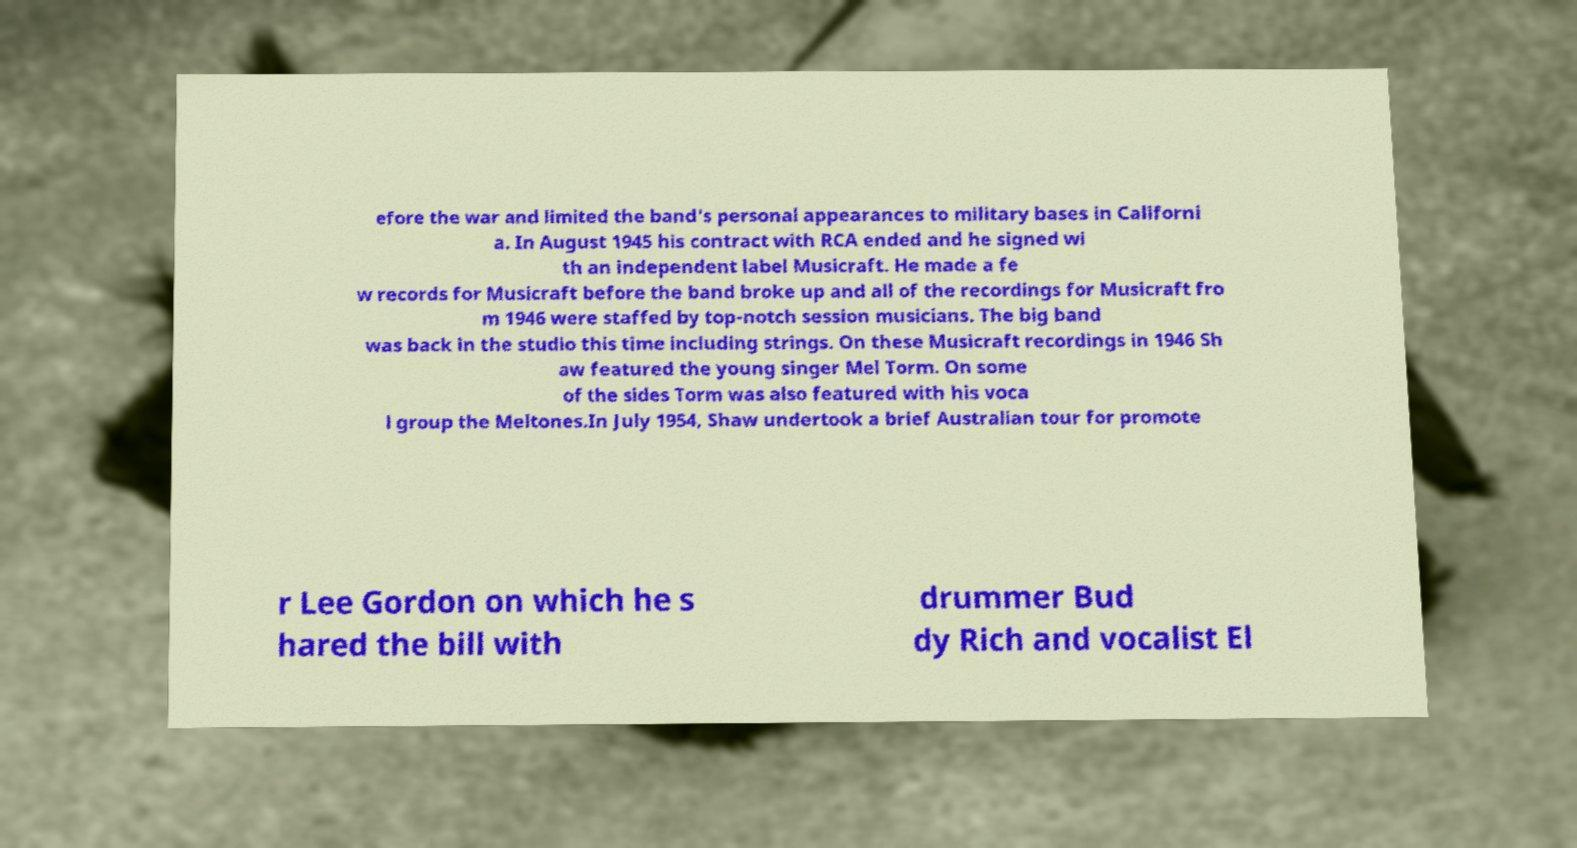There's text embedded in this image that I need extracted. Can you transcribe it verbatim? efore the war and limited the band's personal appearances to military bases in Californi a. In August 1945 his contract with RCA ended and he signed wi th an independent label Musicraft. He made a fe w records for Musicraft before the band broke up and all of the recordings for Musicraft fro m 1946 were staffed by top-notch session musicians. The big band was back in the studio this time including strings. On these Musicraft recordings in 1946 Sh aw featured the young singer Mel Torm. On some of the sides Torm was also featured with his voca l group the Meltones.In July 1954, Shaw undertook a brief Australian tour for promote r Lee Gordon on which he s hared the bill with drummer Bud dy Rich and vocalist El 